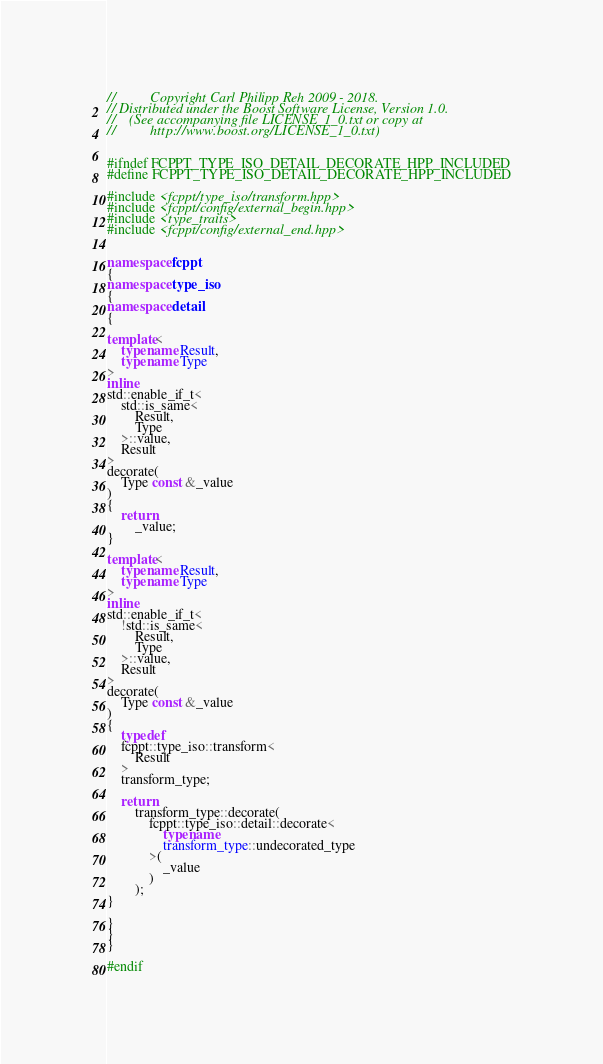Convert code to text. <code><loc_0><loc_0><loc_500><loc_500><_C++_>//          Copyright Carl Philipp Reh 2009 - 2018.
// Distributed under the Boost Software License, Version 1.0.
//    (See accompanying file LICENSE_1_0.txt or copy at
//          http://www.boost.org/LICENSE_1_0.txt)


#ifndef FCPPT_TYPE_ISO_DETAIL_DECORATE_HPP_INCLUDED
#define FCPPT_TYPE_ISO_DETAIL_DECORATE_HPP_INCLUDED

#include <fcppt/type_iso/transform.hpp>
#include <fcppt/config/external_begin.hpp>
#include <type_traits>
#include <fcppt/config/external_end.hpp>


namespace fcppt
{
namespace type_iso
{
namespace detail
{

template<
	typename Result,
	typename Type
>
inline
std::enable_if_t<
	std::is_same<
		Result,
		Type
	>::value,
	Result
>
decorate(
	Type const &_value
)
{
	return
		_value;
}

template<
	typename Result,
	typename Type
>
inline
std::enable_if_t<
	!std::is_same<
		Result,
		Type
	>::value,
	Result
>
decorate(
	Type const &_value
)
{
	typedef
	fcppt::type_iso::transform<
		Result
	>
	transform_type;

	return
		transform_type::decorate(
			fcppt::type_iso::detail::decorate<
				typename
				transform_type::undecorated_type
			>(
				_value
			)
		);
}

}
}
}

#endif
</code> 